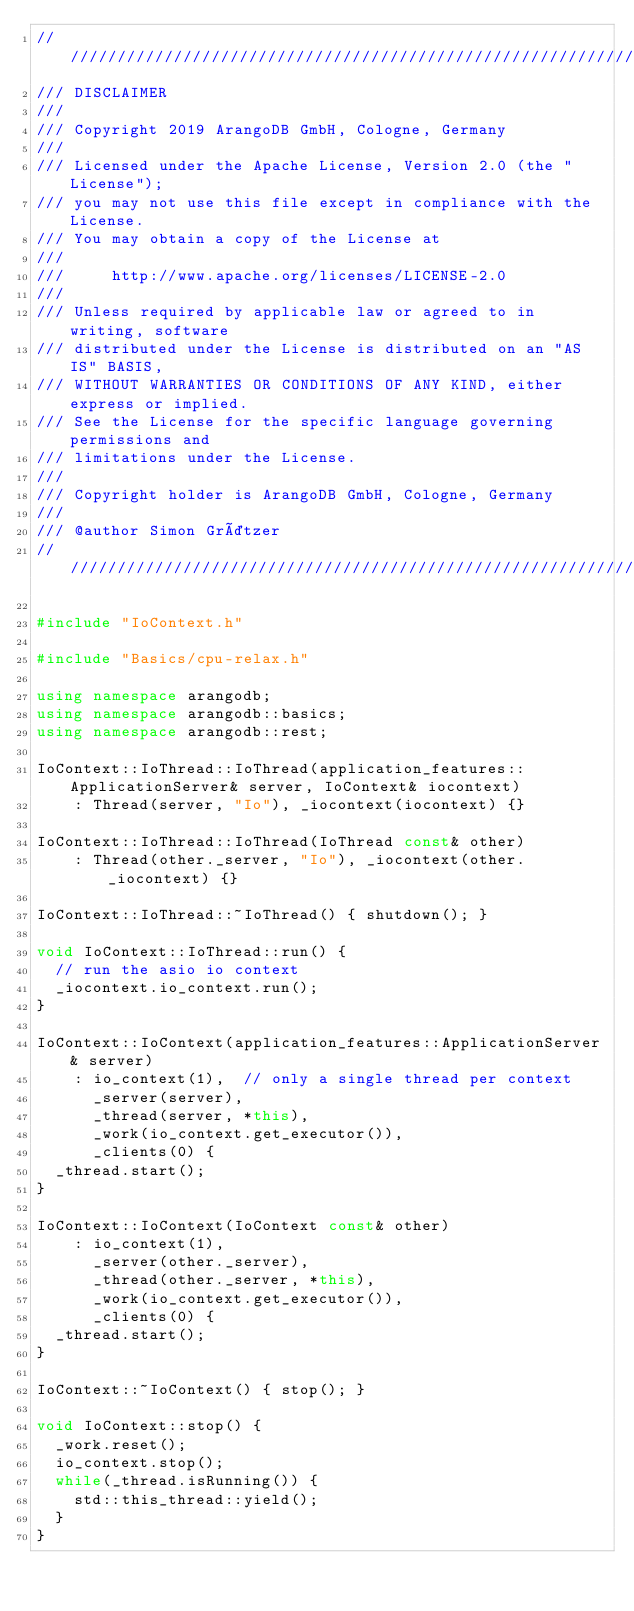Convert code to text. <code><loc_0><loc_0><loc_500><loc_500><_C++_>////////////////////////////////////////////////////////////////////////////////
/// DISCLAIMER
///
/// Copyright 2019 ArangoDB GmbH, Cologne, Germany
///
/// Licensed under the Apache License, Version 2.0 (the "License");
/// you may not use this file except in compliance with the License.
/// You may obtain a copy of the License at
///
///     http://www.apache.org/licenses/LICENSE-2.0
///
/// Unless required by applicable law or agreed to in writing, software
/// distributed under the License is distributed on an "AS IS" BASIS,
/// WITHOUT WARRANTIES OR CONDITIONS OF ANY KIND, either express or implied.
/// See the License for the specific language governing permissions and
/// limitations under the License.
///
/// Copyright holder is ArangoDB GmbH, Cologne, Germany
///
/// @author Simon Grätzer
////////////////////////////////////////////////////////////////////////////////

#include "IoContext.h"

#include "Basics/cpu-relax.h"

using namespace arangodb;
using namespace arangodb::basics;
using namespace arangodb::rest;

IoContext::IoThread::IoThread(application_features::ApplicationServer& server, IoContext& iocontext)
    : Thread(server, "Io"), _iocontext(iocontext) {}

IoContext::IoThread::IoThread(IoThread const& other)
    : Thread(other._server, "Io"), _iocontext(other._iocontext) {}

IoContext::IoThread::~IoThread() { shutdown(); }

void IoContext::IoThread::run() {
  // run the asio io context
  _iocontext.io_context.run();
}

IoContext::IoContext(application_features::ApplicationServer& server)
    : io_context(1),  // only a single thread per context
      _server(server),
      _thread(server, *this),
      _work(io_context.get_executor()),
      _clients(0) {
  _thread.start();
}

IoContext::IoContext(IoContext const& other)
    : io_context(1),
      _server(other._server),
      _thread(other._server, *this),
      _work(io_context.get_executor()),
      _clients(0) {
  _thread.start();
}

IoContext::~IoContext() { stop(); }

void IoContext::stop() {
  _work.reset();
  io_context.stop();
  while(_thread.isRunning()) {
    std::this_thread::yield();
  }
}
</code> 